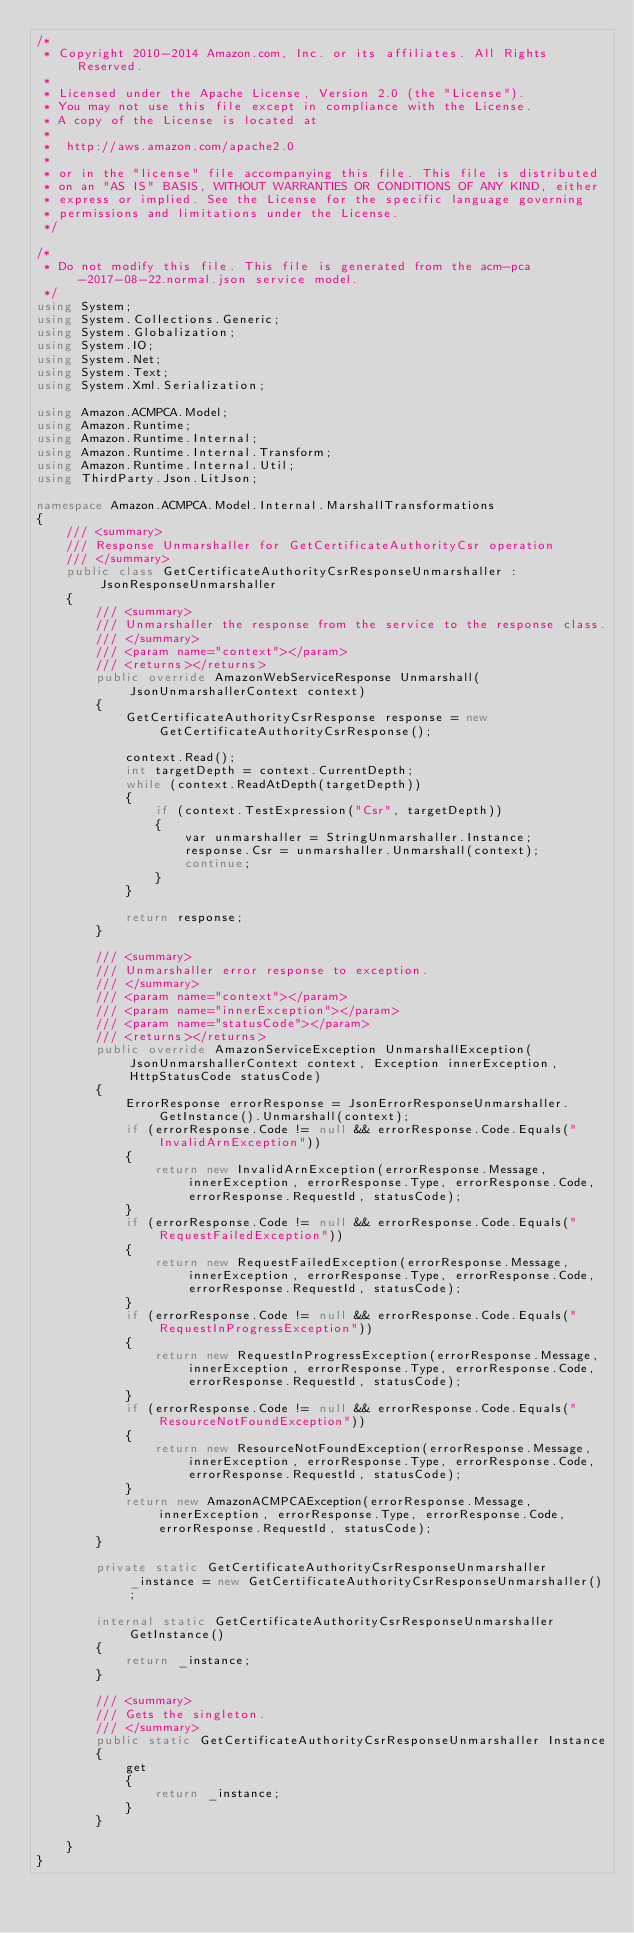<code> <loc_0><loc_0><loc_500><loc_500><_C#_>/*
 * Copyright 2010-2014 Amazon.com, Inc. or its affiliates. All Rights Reserved.
 * 
 * Licensed under the Apache License, Version 2.0 (the "License").
 * You may not use this file except in compliance with the License.
 * A copy of the License is located at
 * 
 *  http://aws.amazon.com/apache2.0
 * 
 * or in the "license" file accompanying this file. This file is distributed
 * on an "AS IS" BASIS, WITHOUT WARRANTIES OR CONDITIONS OF ANY KIND, either
 * express or implied. See the License for the specific language governing
 * permissions and limitations under the License.
 */

/*
 * Do not modify this file. This file is generated from the acm-pca-2017-08-22.normal.json service model.
 */
using System;
using System.Collections.Generic;
using System.Globalization;
using System.IO;
using System.Net;
using System.Text;
using System.Xml.Serialization;

using Amazon.ACMPCA.Model;
using Amazon.Runtime;
using Amazon.Runtime.Internal;
using Amazon.Runtime.Internal.Transform;
using Amazon.Runtime.Internal.Util;
using ThirdParty.Json.LitJson;

namespace Amazon.ACMPCA.Model.Internal.MarshallTransformations
{
    /// <summary>
    /// Response Unmarshaller for GetCertificateAuthorityCsr operation
    /// </summary>  
    public class GetCertificateAuthorityCsrResponseUnmarshaller : JsonResponseUnmarshaller
    {
        /// <summary>
        /// Unmarshaller the response from the service to the response class.
        /// </summary>  
        /// <param name="context"></param>
        /// <returns></returns>
        public override AmazonWebServiceResponse Unmarshall(JsonUnmarshallerContext context)
        {
            GetCertificateAuthorityCsrResponse response = new GetCertificateAuthorityCsrResponse();

            context.Read();
            int targetDepth = context.CurrentDepth;
            while (context.ReadAtDepth(targetDepth))
            {
                if (context.TestExpression("Csr", targetDepth))
                {
                    var unmarshaller = StringUnmarshaller.Instance;
                    response.Csr = unmarshaller.Unmarshall(context);
                    continue;
                }
            }

            return response;
        }

        /// <summary>
        /// Unmarshaller error response to exception.
        /// </summary>  
        /// <param name="context"></param>
        /// <param name="innerException"></param>
        /// <param name="statusCode"></param>
        /// <returns></returns>
        public override AmazonServiceException UnmarshallException(JsonUnmarshallerContext context, Exception innerException, HttpStatusCode statusCode)
        {
            ErrorResponse errorResponse = JsonErrorResponseUnmarshaller.GetInstance().Unmarshall(context);
            if (errorResponse.Code != null && errorResponse.Code.Equals("InvalidArnException"))
            {
                return new InvalidArnException(errorResponse.Message, innerException, errorResponse.Type, errorResponse.Code, errorResponse.RequestId, statusCode);
            }
            if (errorResponse.Code != null && errorResponse.Code.Equals("RequestFailedException"))
            {
                return new RequestFailedException(errorResponse.Message, innerException, errorResponse.Type, errorResponse.Code, errorResponse.RequestId, statusCode);
            }
            if (errorResponse.Code != null && errorResponse.Code.Equals("RequestInProgressException"))
            {
                return new RequestInProgressException(errorResponse.Message, innerException, errorResponse.Type, errorResponse.Code, errorResponse.RequestId, statusCode);
            }
            if (errorResponse.Code != null && errorResponse.Code.Equals("ResourceNotFoundException"))
            {
                return new ResourceNotFoundException(errorResponse.Message, innerException, errorResponse.Type, errorResponse.Code, errorResponse.RequestId, statusCode);
            }
            return new AmazonACMPCAException(errorResponse.Message, innerException, errorResponse.Type, errorResponse.Code, errorResponse.RequestId, statusCode);
        }

        private static GetCertificateAuthorityCsrResponseUnmarshaller _instance = new GetCertificateAuthorityCsrResponseUnmarshaller();        

        internal static GetCertificateAuthorityCsrResponseUnmarshaller GetInstance()
        {
            return _instance;
        }

        /// <summary>
        /// Gets the singleton.
        /// </summary>  
        public static GetCertificateAuthorityCsrResponseUnmarshaller Instance
        {
            get
            {
                return _instance;
            }
        }

    }
}</code> 